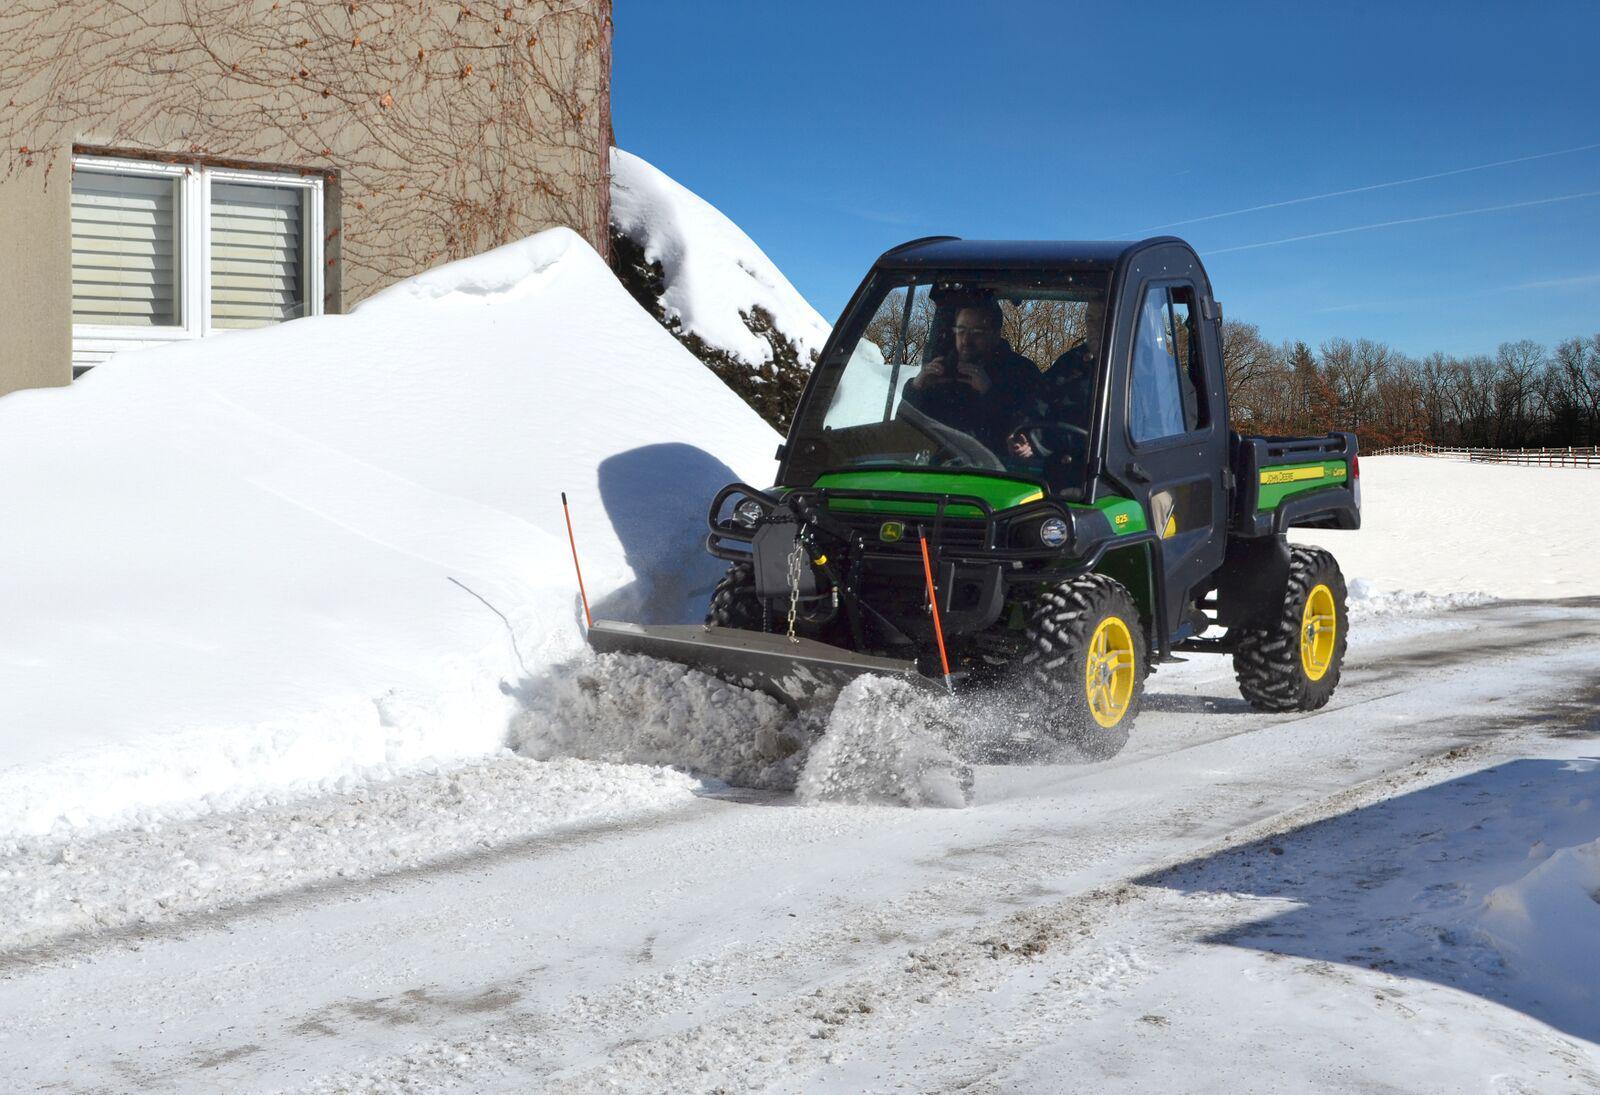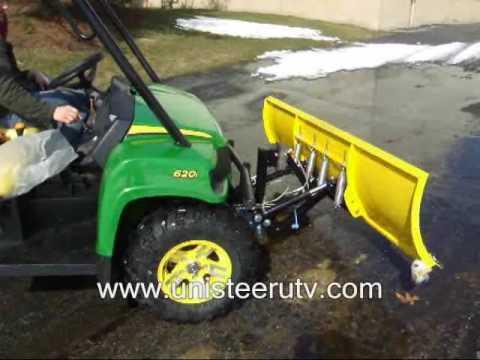The first image is the image on the left, the second image is the image on the right. Considering the images on both sides, is "One image features a vehicle with a red plow." valid? Answer yes or no. No. 